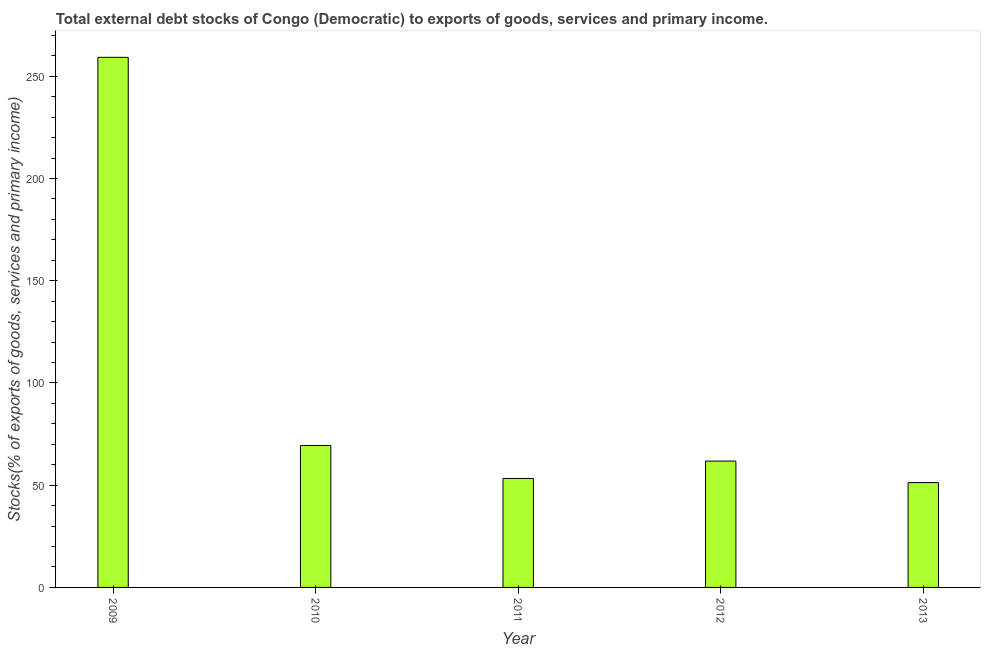Does the graph contain grids?
Your response must be concise. No. What is the title of the graph?
Make the answer very short. Total external debt stocks of Congo (Democratic) to exports of goods, services and primary income. What is the label or title of the X-axis?
Provide a short and direct response. Year. What is the label or title of the Y-axis?
Ensure brevity in your answer.  Stocks(% of exports of goods, services and primary income). What is the external debt stocks in 2013?
Offer a terse response. 51.27. Across all years, what is the maximum external debt stocks?
Your answer should be very brief. 259.23. Across all years, what is the minimum external debt stocks?
Give a very brief answer. 51.27. In which year was the external debt stocks minimum?
Keep it short and to the point. 2013. What is the sum of the external debt stocks?
Offer a very short reply. 494.99. What is the difference between the external debt stocks in 2010 and 2012?
Make the answer very short. 7.63. What is the average external debt stocks per year?
Provide a short and direct response. 99. What is the median external debt stocks?
Offer a terse response. 61.78. Do a majority of the years between 2011 and 2012 (inclusive) have external debt stocks greater than 90 %?
Give a very brief answer. No. What is the ratio of the external debt stocks in 2011 to that in 2012?
Keep it short and to the point. 0.86. Is the external debt stocks in 2009 less than that in 2013?
Make the answer very short. No. Is the difference between the external debt stocks in 2011 and 2012 greater than the difference between any two years?
Your answer should be compact. No. What is the difference between the highest and the second highest external debt stocks?
Keep it short and to the point. 189.82. Is the sum of the external debt stocks in 2009 and 2011 greater than the maximum external debt stocks across all years?
Your answer should be very brief. Yes. What is the difference between the highest and the lowest external debt stocks?
Your response must be concise. 207.96. Are the values on the major ticks of Y-axis written in scientific E-notation?
Provide a short and direct response. No. What is the Stocks(% of exports of goods, services and primary income) of 2009?
Offer a very short reply. 259.23. What is the Stocks(% of exports of goods, services and primary income) of 2010?
Offer a terse response. 69.42. What is the Stocks(% of exports of goods, services and primary income) in 2011?
Your answer should be compact. 53.28. What is the Stocks(% of exports of goods, services and primary income) of 2012?
Your answer should be compact. 61.78. What is the Stocks(% of exports of goods, services and primary income) in 2013?
Provide a short and direct response. 51.27. What is the difference between the Stocks(% of exports of goods, services and primary income) in 2009 and 2010?
Give a very brief answer. 189.82. What is the difference between the Stocks(% of exports of goods, services and primary income) in 2009 and 2011?
Keep it short and to the point. 205.95. What is the difference between the Stocks(% of exports of goods, services and primary income) in 2009 and 2012?
Your response must be concise. 197.45. What is the difference between the Stocks(% of exports of goods, services and primary income) in 2009 and 2013?
Make the answer very short. 207.96. What is the difference between the Stocks(% of exports of goods, services and primary income) in 2010 and 2011?
Ensure brevity in your answer.  16.13. What is the difference between the Stocks(% of exports of goods, services and primary income) in 2010 and 2012?
Give a very brief answer. 7.63. What is the difference between the Stocks(% of exports of goods, services and primary income) in 2010 and 2013?
Offer a terse response. 18.15. What is the difference between the Stocks(% of exports of goods, services and primary income) in 2011 and 2012?
Provide a short and direct response. -8.5. What is the difference between the Stocks(% of exports of goods, services and primary income) in 2011 and 2013?
Your response must be concise. 2.01. What is the difference between the Stocks(% of exports of goods, services and primary income) in 2012 and 2013?
Your answer should be very brief. 10.51. What is the ratio of the Stocks(% of exports of goods, services and primary income) in 2009 to that in 2010?
Give a very brief answer. 3.73. What is the ratio of the Stocks(% of exports of goods, services and primary income) in 2009 to that in 2011?
Your response must be concise. 4.87. What is the ratio of the Stocks(% of exports of goods, services and primary income) in 2009 to that in 2012?
Provide a short and direct response. 4.2. What is the ratio of the Stocks(% of exports of goods, services and primary income) in 2009 to that in 2013?
Your answer should be compact. 5.06. What is the ratio of the Stocks(% of exports of goods, services and primary income) in 2010 to that in 2011?
Make the answer very short. 1.3. What is the ratio of the Stocks(% of exports of goods, services and primary income) in 2010 to that in 2012?
Make the answer very short. 1.12. What is the ratio of the Stocks(% of exports of goods, services and primary income) in 2010 to that in 2013?
Provide a short and direct response. 1.35. What is the ratio of the Stocks(% of exports of goods, services and primary income) in 2011 to that in 2012?
Offer a very short reply. 0.86. What is the ratio of the Stocks(% of exports of goods, services and primary income) in 2011 to that in 2013?
Your answer should be very brief. 1.04. What is the ratio of the Stocks(% of exports of goods, services and primary income) in 2012 to that in 2013?
Your answer should be compact. 1.21. 